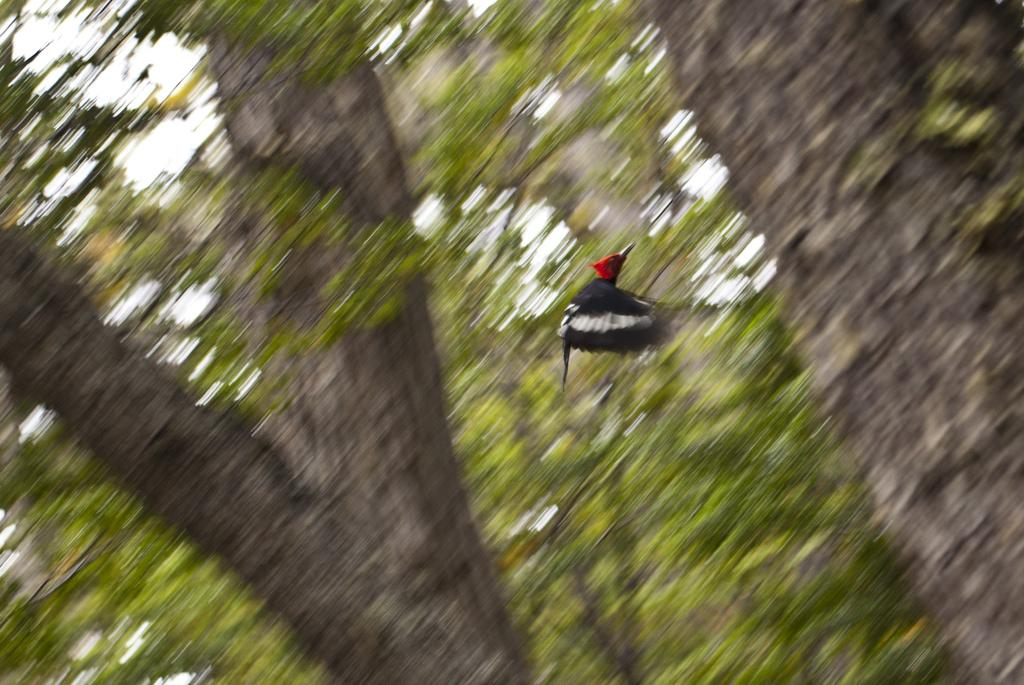What is the main subject of the image? There is a bird in the center of the image. What can be seen in the background of the image? There are trees in the background of the image. What type of mask is the bird wearing in the image? There is no mask present on the bird in the image. How does the bird's brain help it navigate in the image? The image does not provide information about the bird's brain or its ability to navigate. 